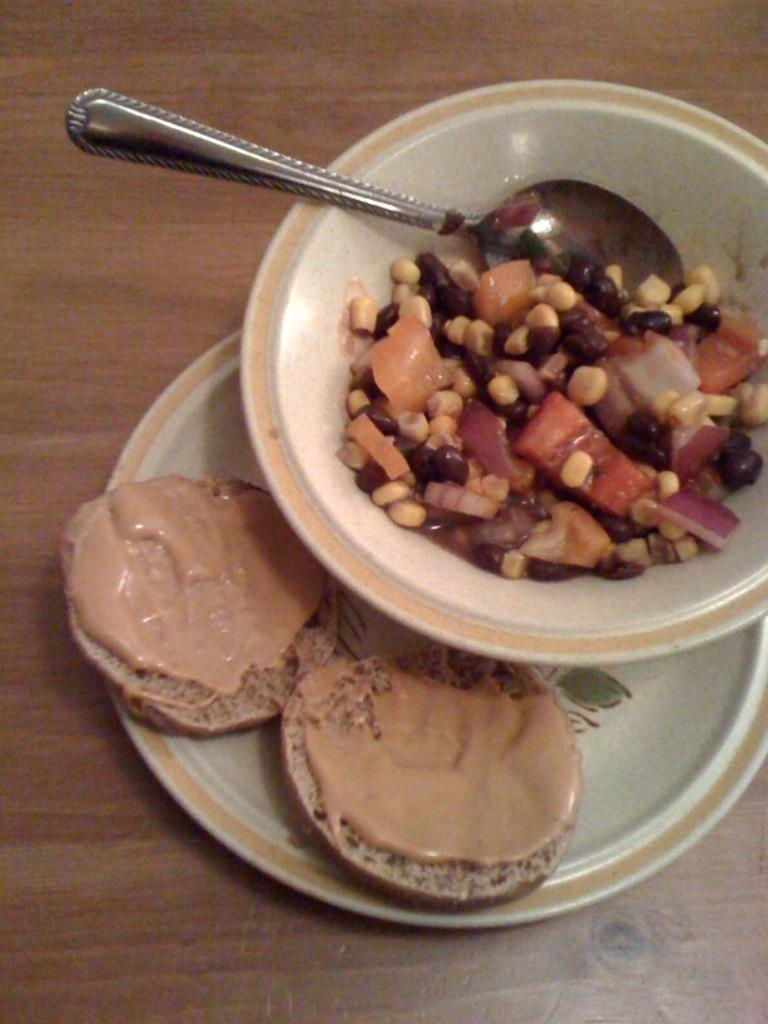What type of food is in the bowl in the image? There are veggies in a bowl in the image. What utensil is visible in the image? There is a spoon visible in the image. What is on the plate in the image? There is bread with cream in a plate in the image. What piece of furniture is present in the image? There is a table in the image. Reasoning: Let' Let's think step by step in order to produce the conversation. We start by identifying the main food items in the image, which are the veggies in the bowl and the bread with cream on the plate. Then, we mention the utensil that is visible, which is the spoon. Finally, we acknowledge the presence of a table in the image. Absurd Question/Answer: What type of wound can be seen on the foot of the person in the image? There is no person or foot present in the image, so it is not possible to determine if there is a wound. What type of wound can be seen on the foot of the person in the image? There is no person or foot present in the image, so it is not possible to determine if there is a wound. 